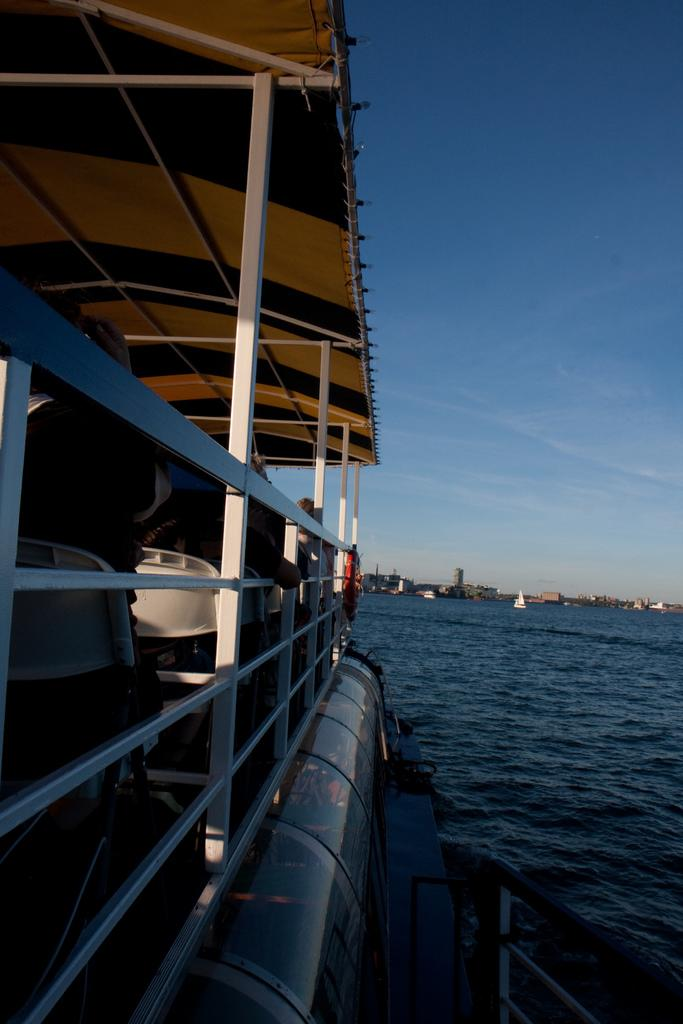What is the main subject of the image? The main subject of the image is a boat. Where is the boat located? The boat is on the water. Are there any people in the boat? Yes, there are people in the boat. What can be seen in the background of the image? There are clouds visible in the background of the image. What type of meal is being served on the boat in the image? There is no indication of a meal being served on the boat in the image. 